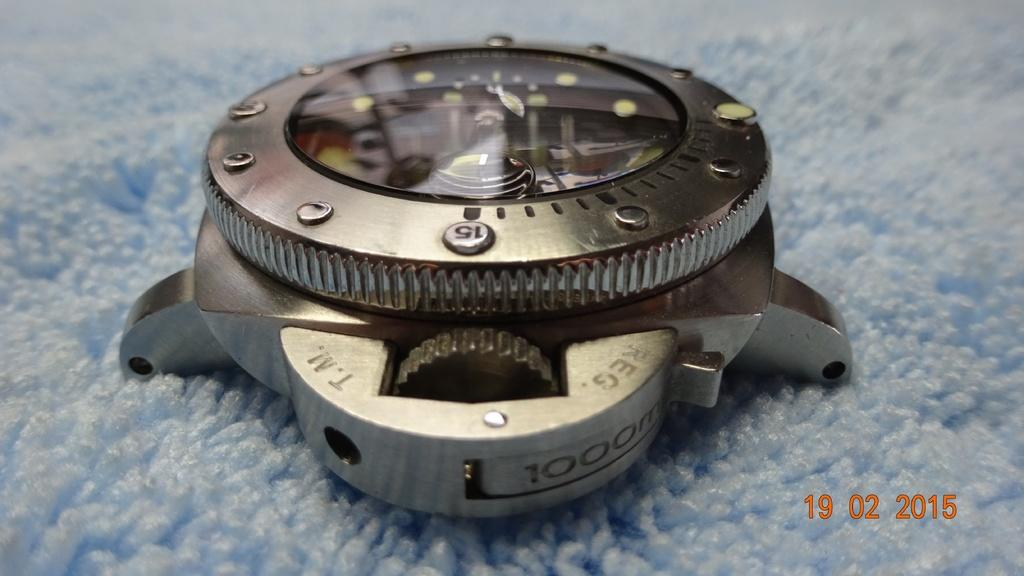<image>
Describe the image concisely. A watch face that has the words REG and T.M. on it. 